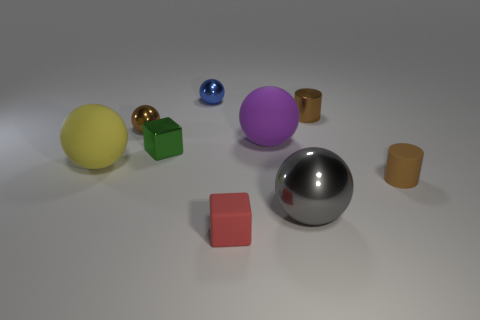The small shiny object that is the same shape as the tiny brown matte thing is what color?
Your response must be concise. Brown. Are there more gray spheres than small purple metal spheres?
Your answer should be compact. Yes. What number of other objects are the same material as the tiny green block?
Offer a very short reply. 4. What shape is the small rubber object that is in front of the small brown cylinder in front of the brown cylinder to the left of the brown matte thing?
Keep it short and to the point. Cube. Are there fewer big yellow matte spheres right of the yellow ball than balls left of the large gray ball?
Make the answer very short. Yes. Are there any large objects of the same color as the tiny rubber block?
Keep it short and to the point. No. Is the big gray ball made of the same material as the object in front of the large gray thing?
Ensure brevity in your answer.  No. Is there a tiny ball on the left side of the rubber sphere on the right side of the metallic block?
Your answer should be very brief. Yes. What color is the big thing that is both behind the big gray metallic object and right of the tiny green metal thing?
Your answer should be very brief. Purple. The gray shiny object is what size?
Provide a short and direct response. Large. 